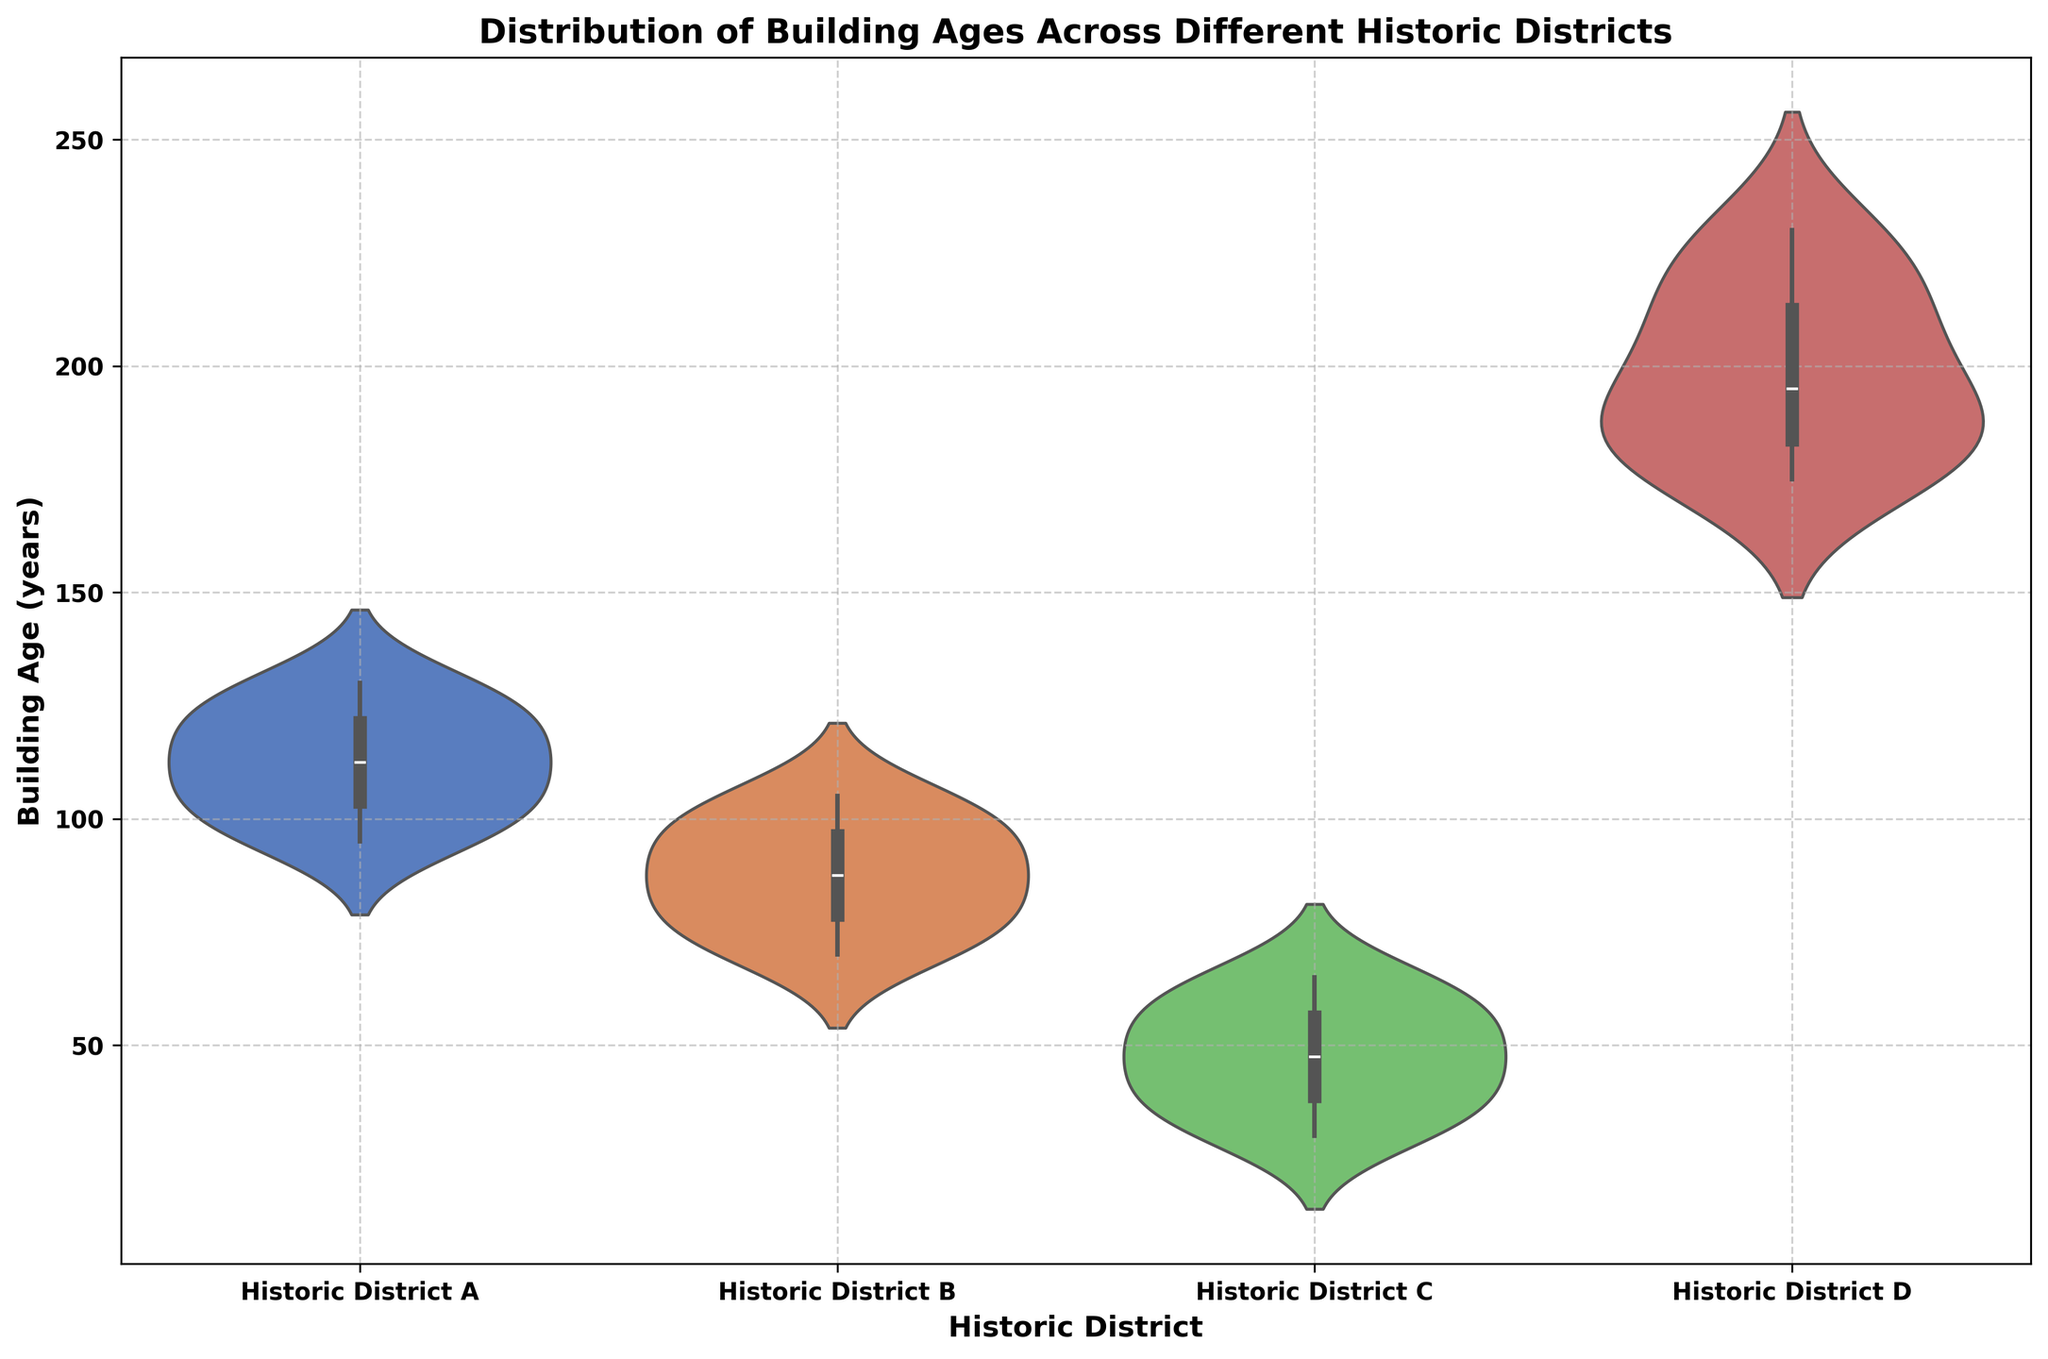What is the median building age for Historic District A? To find the median, we need to arrange the building ages in Historic District A in increasing order: 95, 100, 105, 110, 115, 120, 125, 130. The middle value or the median is the average of the 4th and 5th values, which are both 110 and 115. Hence, the median is (110+115)/2 = 112.5.
Answer: 112.5 Which historic district has the widest range of building ages? The range is calculated by subtracting the minimum age from the maximum age within each district. In Historic District D, ages range from 175 to 230, giving a range of 55 years. This is the widest range, as no other district has such a wide spread.
Answer: Historic District D What is the interquartile range (IQR) for Historic District C? The IQR is the difference between the third quartile (Q3) and the first quartile (Q1). By observing the violin plot, the ages for Historic District C are visually divided into approx. quartiles: Q1 is around 35, and Q3 is around 55. Therefore, IQR = Q3 - Q1 = 55 - 35 = 20.
Answer: 20 Which historic district has the highest median building age? Upon visual inspection of the violin plot, Historic District D shows a median building age that is higher than those of the other districts.
Answer: Historic District D Compare the median building ages of Historic District A and Historic District B. Which one is greater? By examining the violin plot, Historic District A has a median value around 112.5, while Historic District B has a median of around 90. Therefore, Historic District A's median is greater.
Answer: Historic District A What is the smallest building age recorded in Historic District B? The minimum age in Historic District B can be seen at the bottom of its violin plot, which is at 70 years.
Answer: 70 How many historic districts have a maximum building age over 100 years? From the observation, Historic Districts A, B, and D all have maximum building ages over 100 years, thus there are 3 districts.
Answer: 3 Which historic district has the narrowest distribution of building ages? By observing the width of each violin plot's bulges or the range covered, Historic District C has the narrowest distribution with building ages tightly clustered around the middle.
Answer: Historic District C What is the difference between the oldest building ages in Historic District A and Historic District D? The maximum building age in Historic District A is 130 years, and in Historic District D it is 230 years. The difference is 230 - 130 = 100 years.
Answer: 100 Without considering specific numbers, which district visually seems to have the most symmetrically distributed building ages? Symmetry is when the shape on one side of the middle line mirrors the shape on the other side. By visual inspection, Historic District B appears to have the most symmetrical distribution.
Answer: Historic District B 